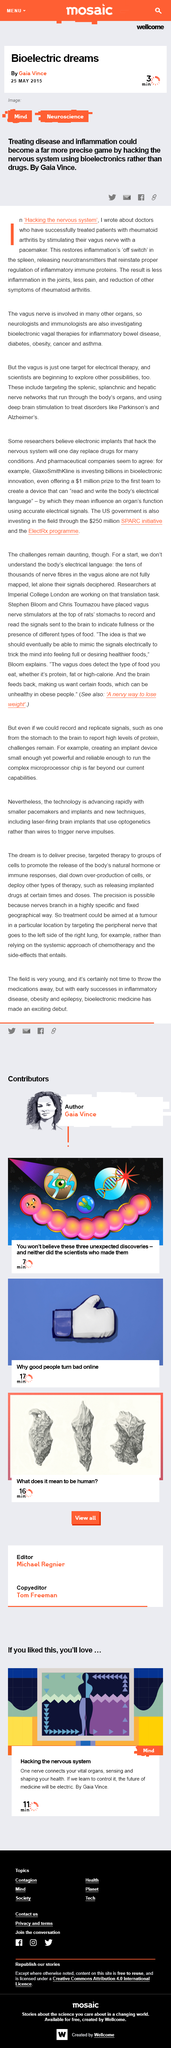Indicate a few pertinent items in this graphic. The patient will experience a reduction in joint inflammation, pain, and symptoms of rheumatoid arthritis as a result of the treatment. The doctors successfully treated patients with rheumatoid arthritis by stimulating their vagus nerve with a pacemaker. Instead of using drugs to manipulate the nervous system, bioelectronics are being utilized as a new and innovative approach to achieve the same effects. 